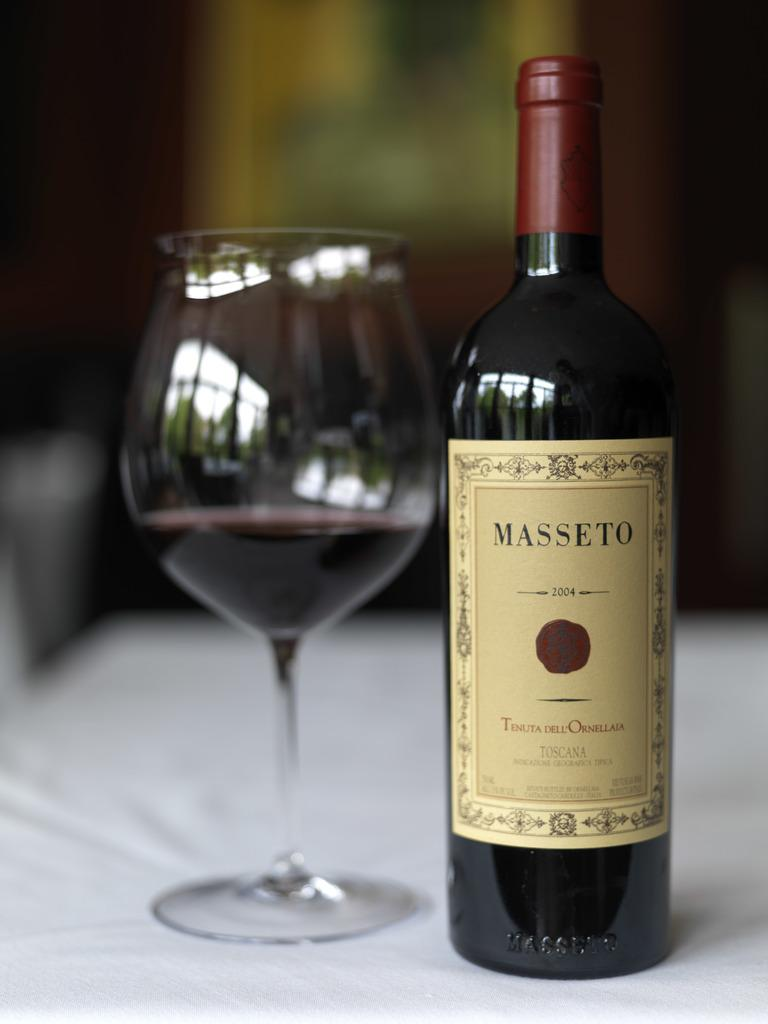<image>
Describe the image concisely. A bottle of Masseto wine is from 2004, per the label.. 